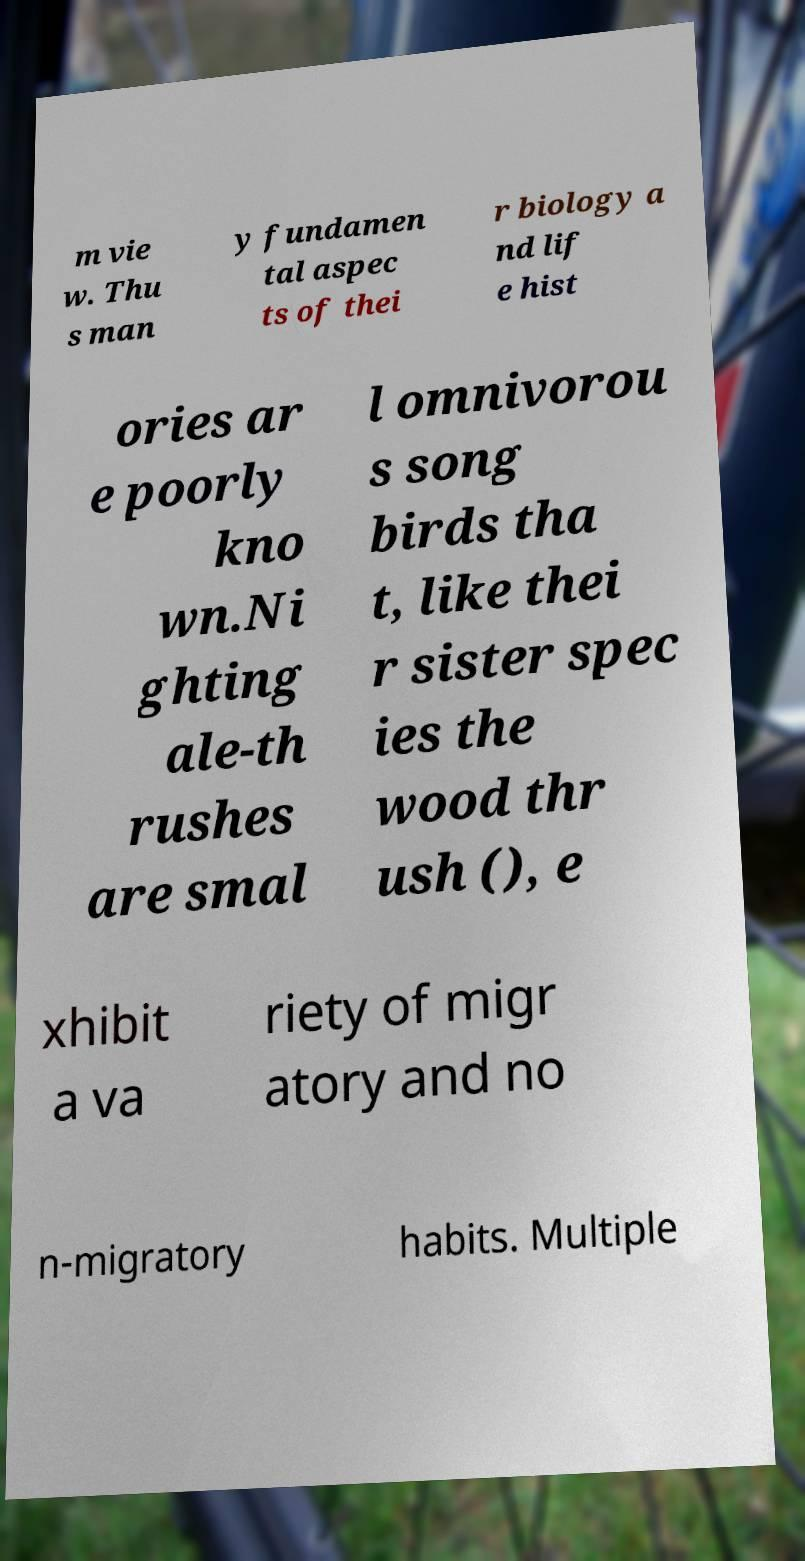There's text embedded in this image that I need extracted. Can you transcribe it verbatim? m vie w. Thu s man y fundamen tal aspec ts of thei r biology a nd lif e hist ories ar e poorly kno wn.Ni ghting ale-th rushes are smal l omnivorou s song birds tha t, like thei r sister spec ies the wood thr ush (), e xhibit a va riety of migr atory and no n-migratory habits. Multiple 